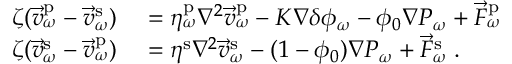<formula> <loc_0><loc_0><loc_500><loc_500>\begin{array} { r l } { \zeta ( \vec { v } _ { \omega } ^ { p } - \vec { v } _ { \omega } ^ { s } ) } & = \eta _ { \omega } ^ { p } \nabla ^ { 2 } \vec { v } _ { \omega } ^ { p } - K \nabla \delta \phi _ { \omega } - \phi _ { 0 } \nabla P _ { \omega } + \vec { F } _ { \omega } ^ { p } } \\ { \zeta ( \vec { v } _ { \omega } ^ { s } - \vec { v } _ { \omega } ^ { p } ) } & = \eta ^ { s } \nabla ^ { 2 } \vec { v } _ { \omega } ^ { s } - ( 1 - \phi _ { 0 } ) \nabla P _ { \omega } + \vec { F } _ { \omega } ^ { s } \, . } \end{array}</formula> 